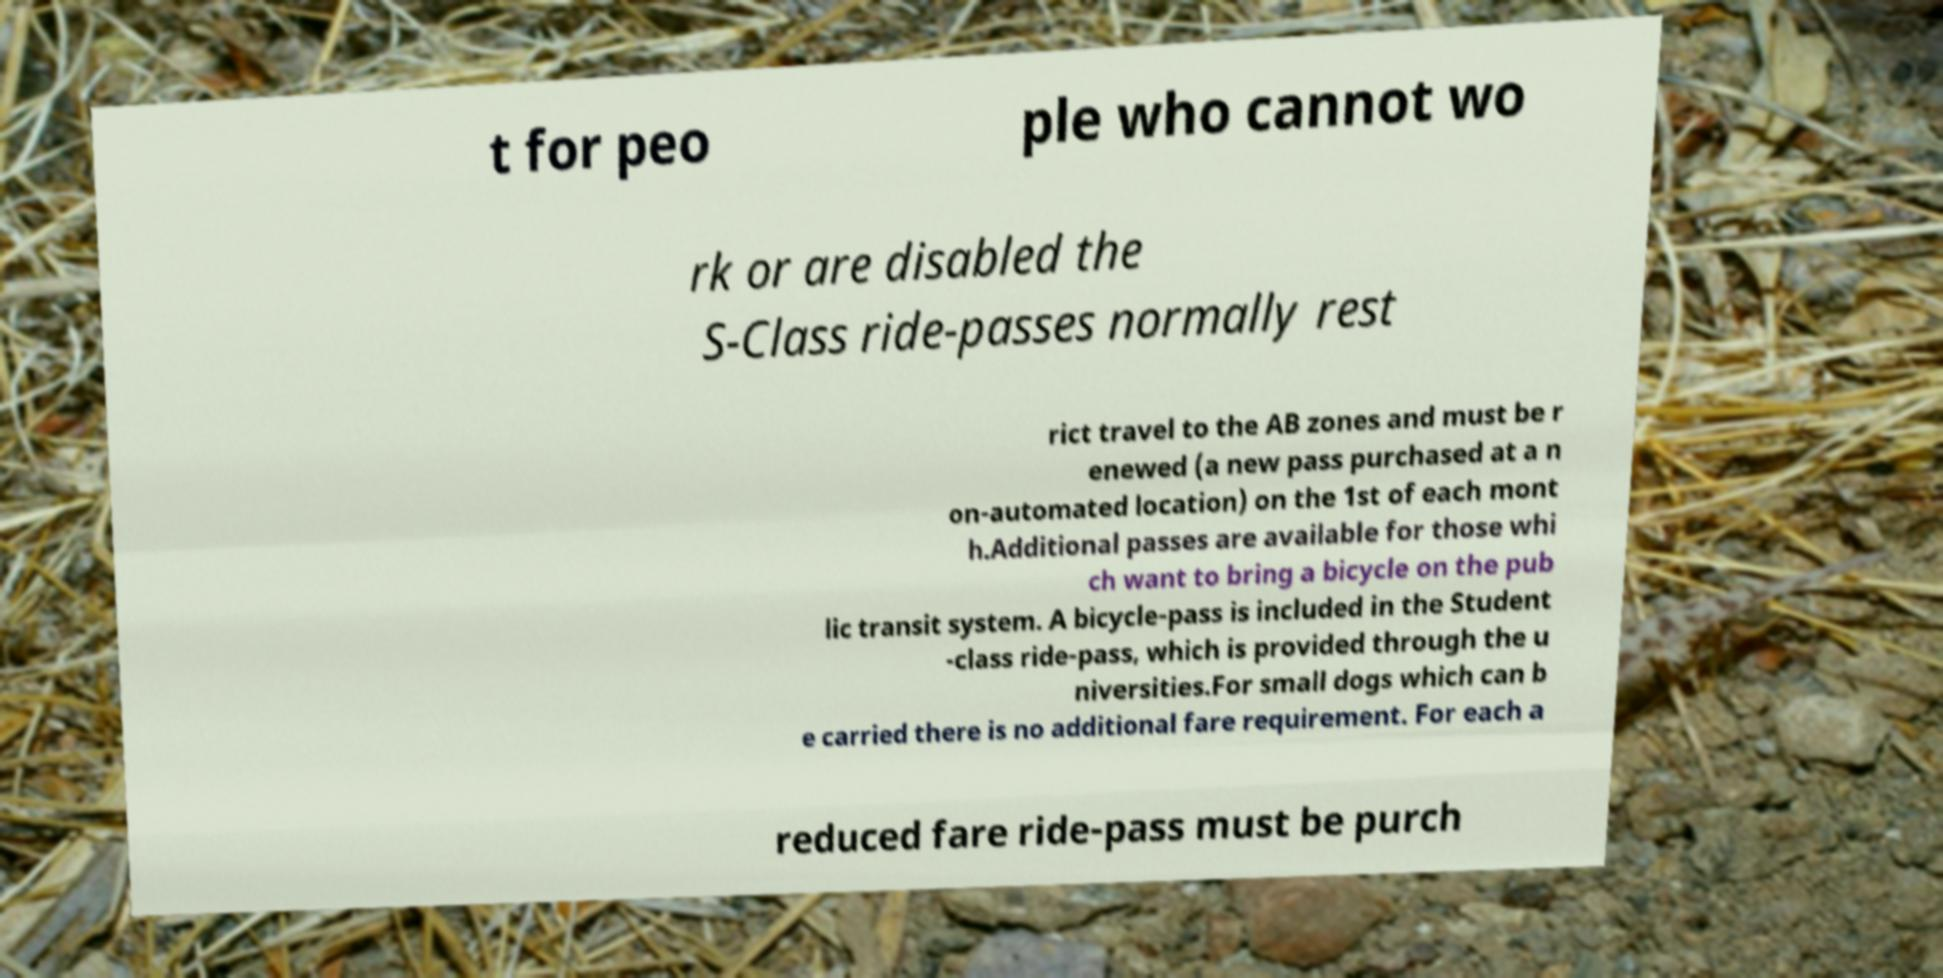Could you extract and type out the text from this image? t for peo ple who cannot wo rk or are disabled the S-Class ride-passes normally rest rict travel to the AB zones and must be r enewed (a new pass purchased at a n on-automated location) on the 1st of each mont h.Additional passes are available for those whi ch want to bring a bicycle on the pub lic transit system. A bicycle-pass is included in the Student -class ride-pass, which is provided through the u niversities.For small dogs which can b e carried there is no additional fare requirement. For each a reduced fare ride-pass must be purch 